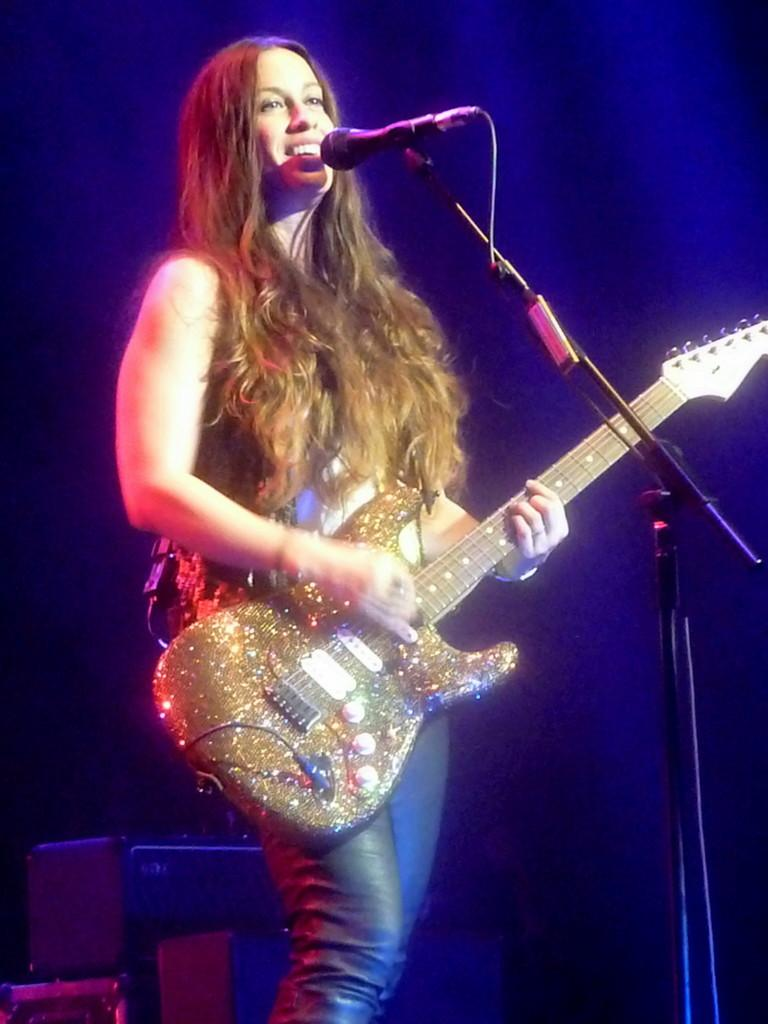What is the main subject of the image? The main subject of the image is a woman. What is the woman doing in the image? The woman is standing in front of a mic and holding a guitar. What is the woman's facial expression in the image? The woman is smiling in the image. What type of flag is being waved by the woman in the image? There is no flag present in the image. What activity is the woman participating in that requires her to maintain good health? The image does not provide information about any specific activity or the woman's health. 